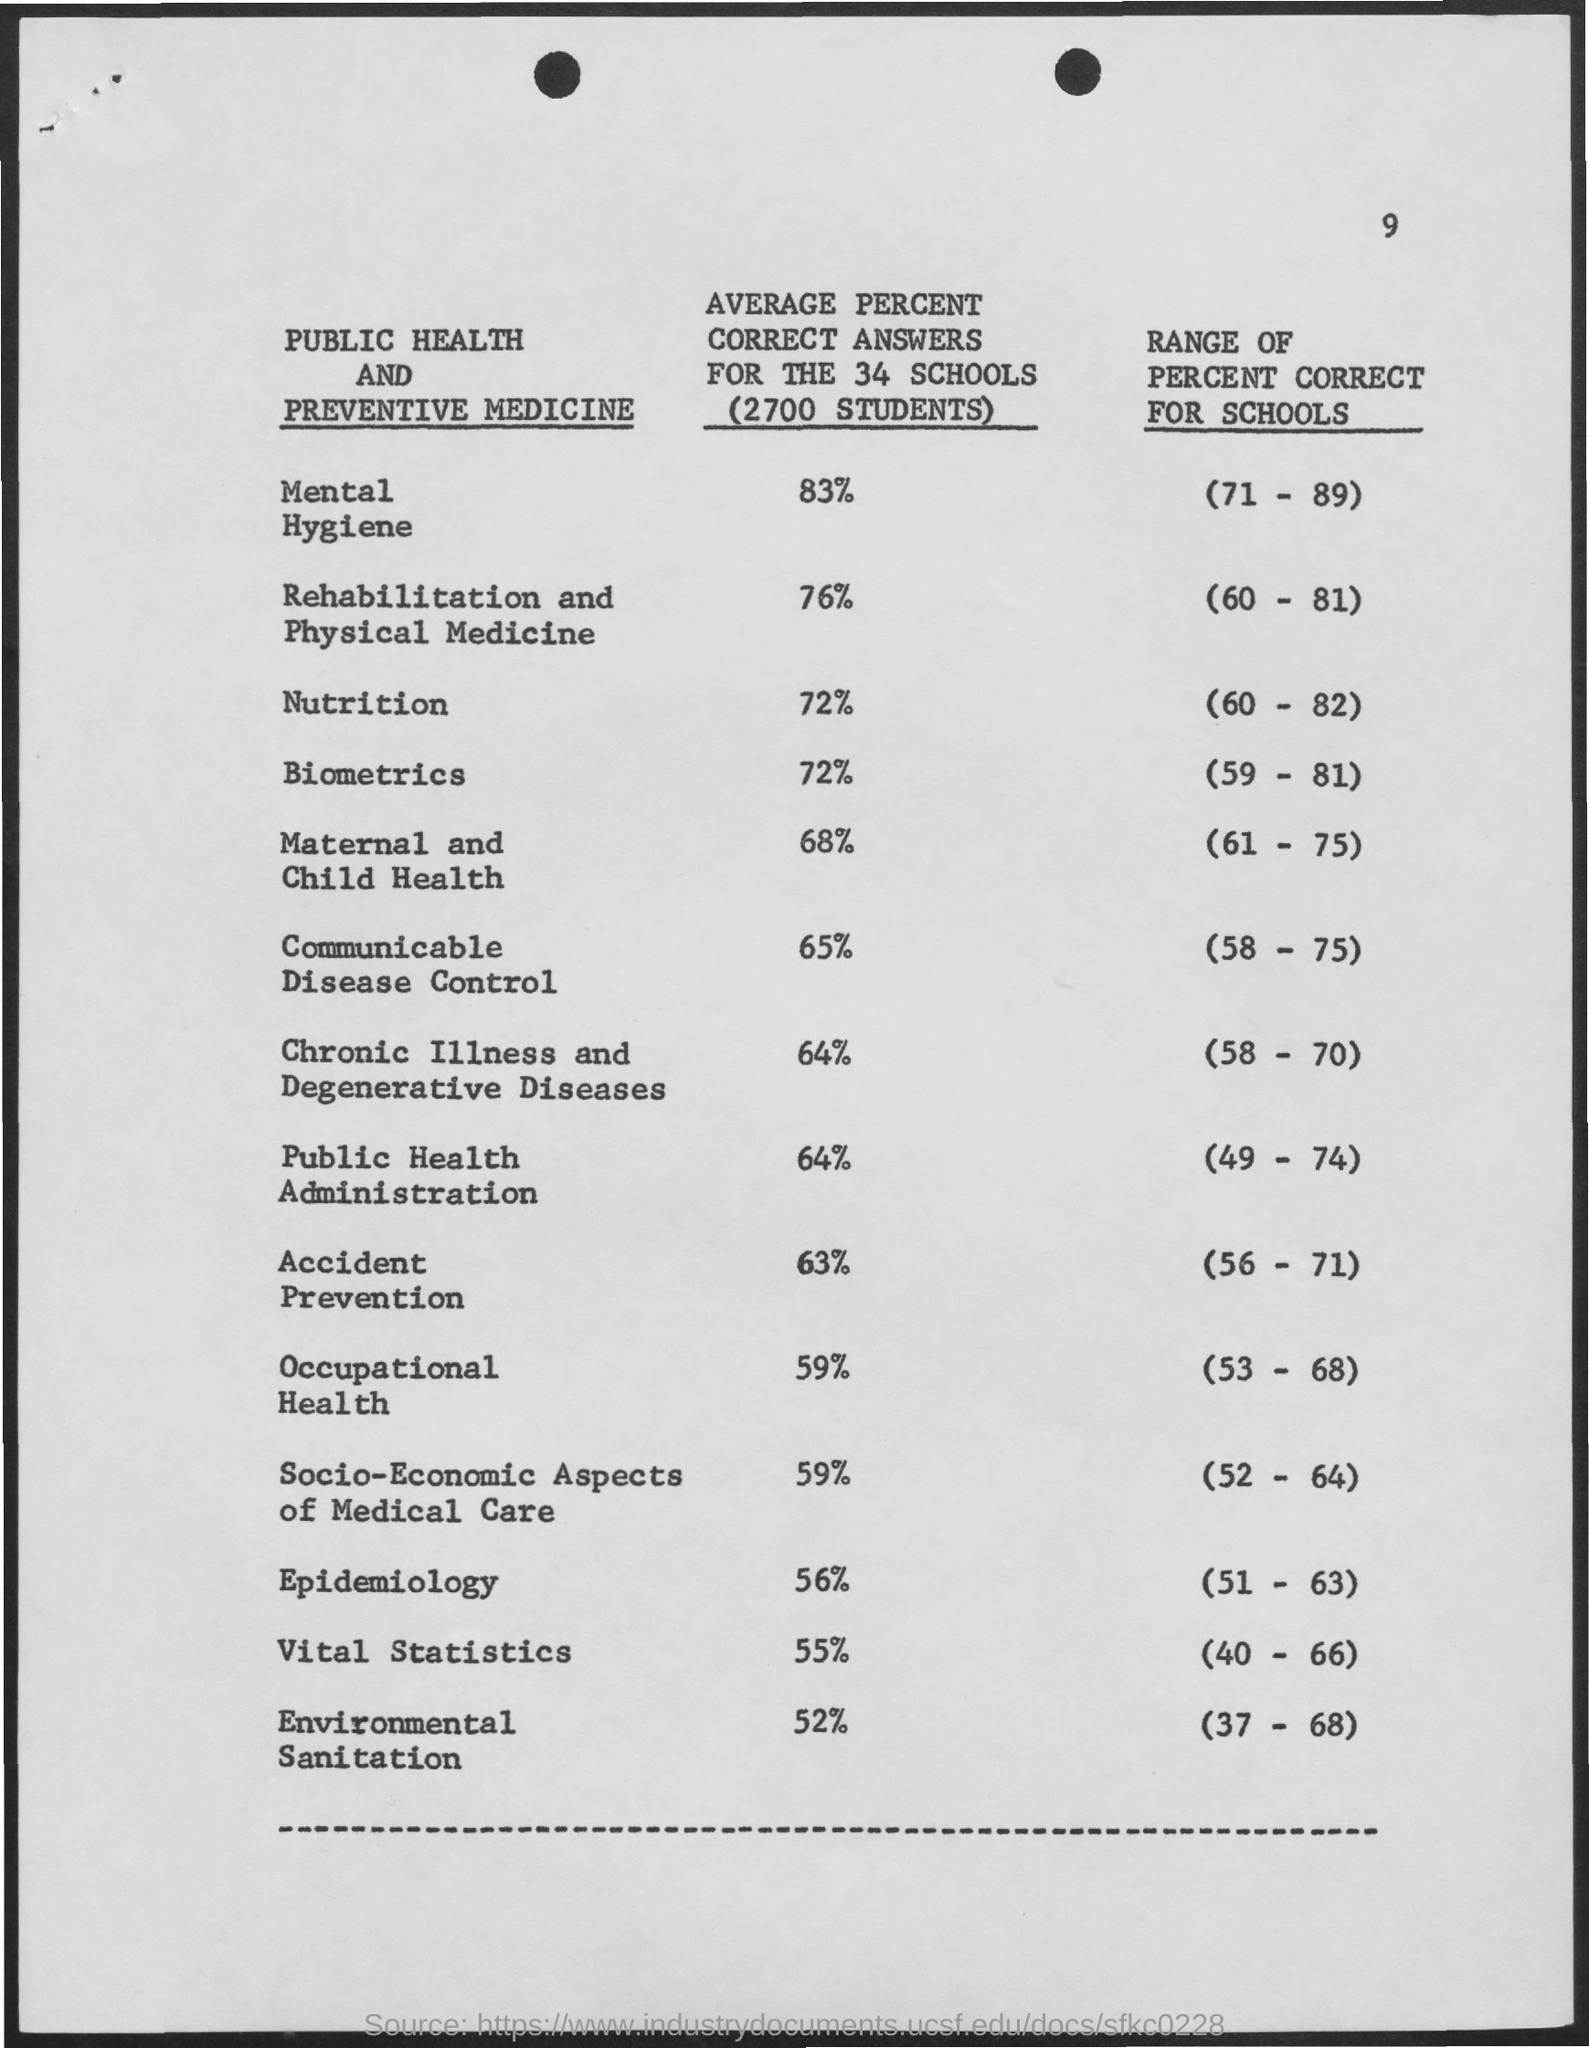Indicate a few pertinent items in this graphic. The page number is 9. 